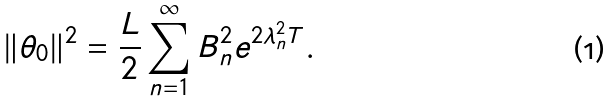Convert formula to latex. <formula><loc_0><loc_0><loc_500><loc_500>\| \theta _ { 0 } \| ^ { 2 } = \frac { L } { 2 } \sum _ { n = 1 } ^ { \infty } B _ { n } ^ { 2 } e ^ { 2 \lambda _ { n } ^ { 2 } T } .</formula> 